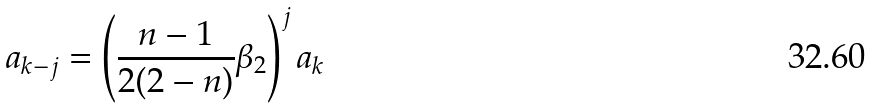<formula> <loc_0><loc_0><loc_500><loc_500>a _ { k - j } = \left ( \frac { n - 1 } { 2 ( 2 - n ) } \beta _ { 2 } \right ) ^ { j } a _ { k }</formula> 